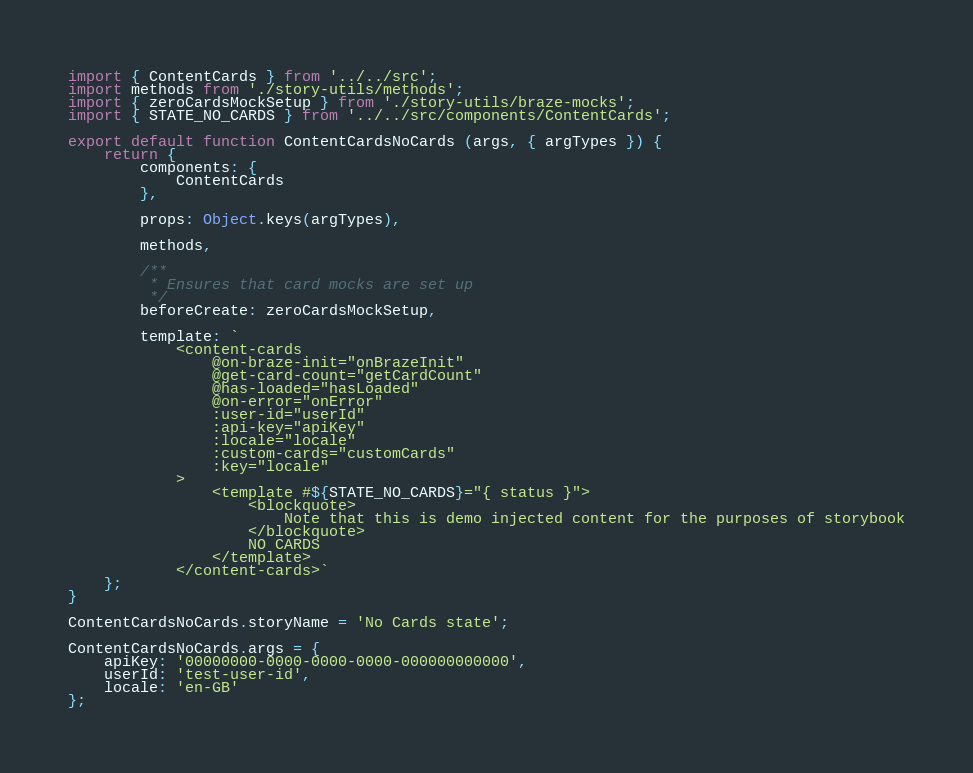Convert code to text. <code><loc_0><loc_0><loc_500><loc_500><_JavaScript_>import { ContentCards } from '../../src';
import methods from './story-utils/methods';
import { zeroCardsMockSetup } from './story-utils/braze-mocks';
import { STATE_NO_CARDS } from '../../src/components/ContentCards';

export default function ContentCardsNoCards (args, { argTypes }) {
    return {
        components: {
            ContentCards
        },

        props: Object.keys(argTypes),

        methods,

        /**
         * Ensures that card mocks are set up
         */
        beforeCreate: zeroCardsMockSetup,

        template: `
            <content-cards
                @on-braze-init="onBrazeInit"
                @get-card-count="getCardCount"
                @has-loaded="hasLoaded"
                @on-error="onError"
                :user-id="userId"
                :api-key="apiKey"
                :locale="locale"
                :custom-cards="customCards"
                :key="locale"
            >
                <template #${STATE_NO_CARDS}="{ status }">
                    <blockquote>
                        Note that this is demo injected content for the purposes of storybook
                    </blockquote>
                    NO CARDS
                </template>
            </content-cards>`
    };
}

ContentCardsNoCards.storyName = 'No Cards state';

ContentCardsNoCards.args = {
    apiKey: '00000000-0000-0000-0000-000000000000',
    userId: 'test-user-id',
    locale: 'en-GB'
};
</code> 